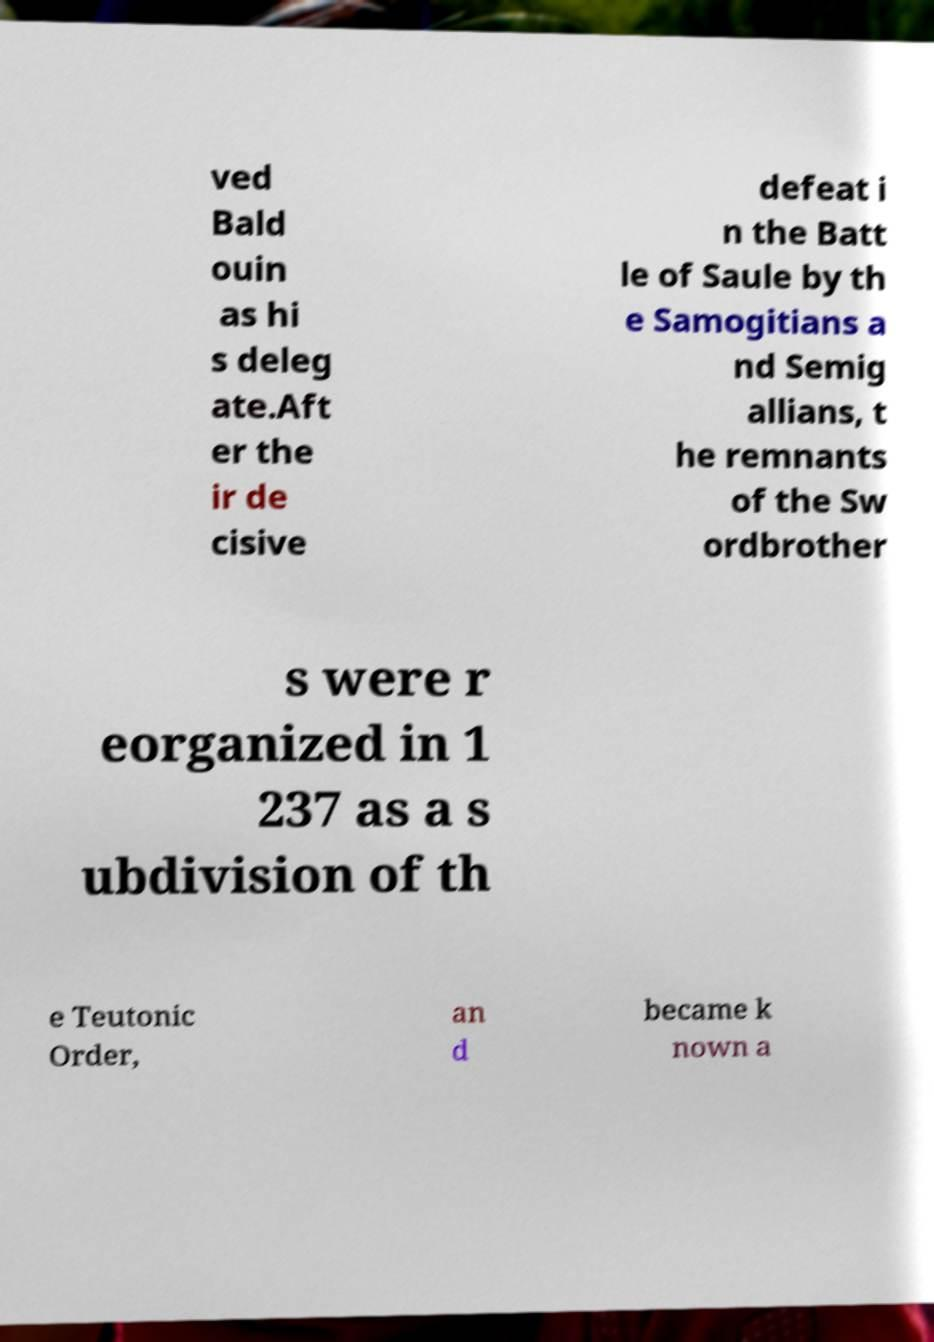Can you read and provide the text displayed in the image?This photo seems to have some interesting text. Can you extract and type it out for me? ved Bald ouin as hi s deleg ate.Aft er the ir de cisive defeat i n the Batt le of Saule by th e Samogitians a nd Semig allians, t he remnants of the Sw ordbrother s were r eorganized in 1 237 as a s ubdivision of th e Teutonic Order, an d became k nown a 